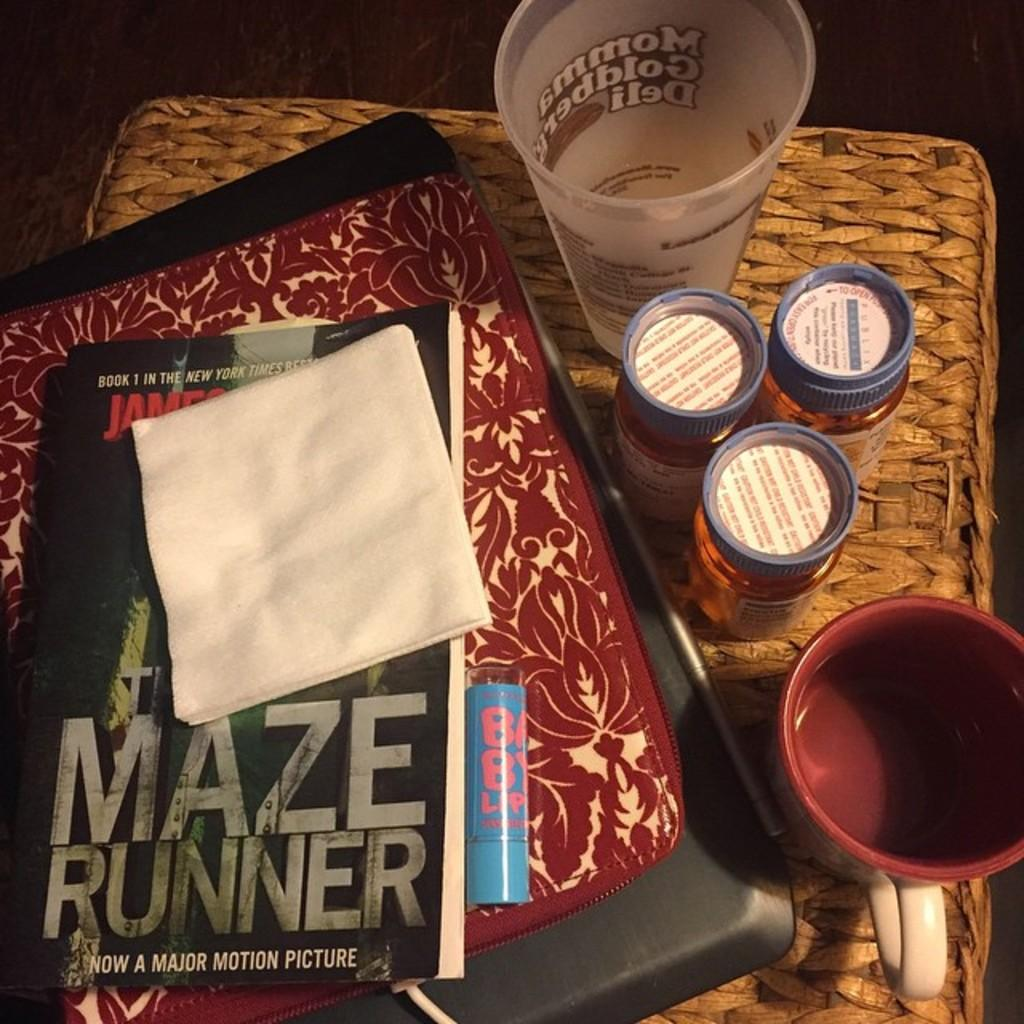Provide a one-sentence caption for the provided image. The Maze Runner book has a napkin on it. 